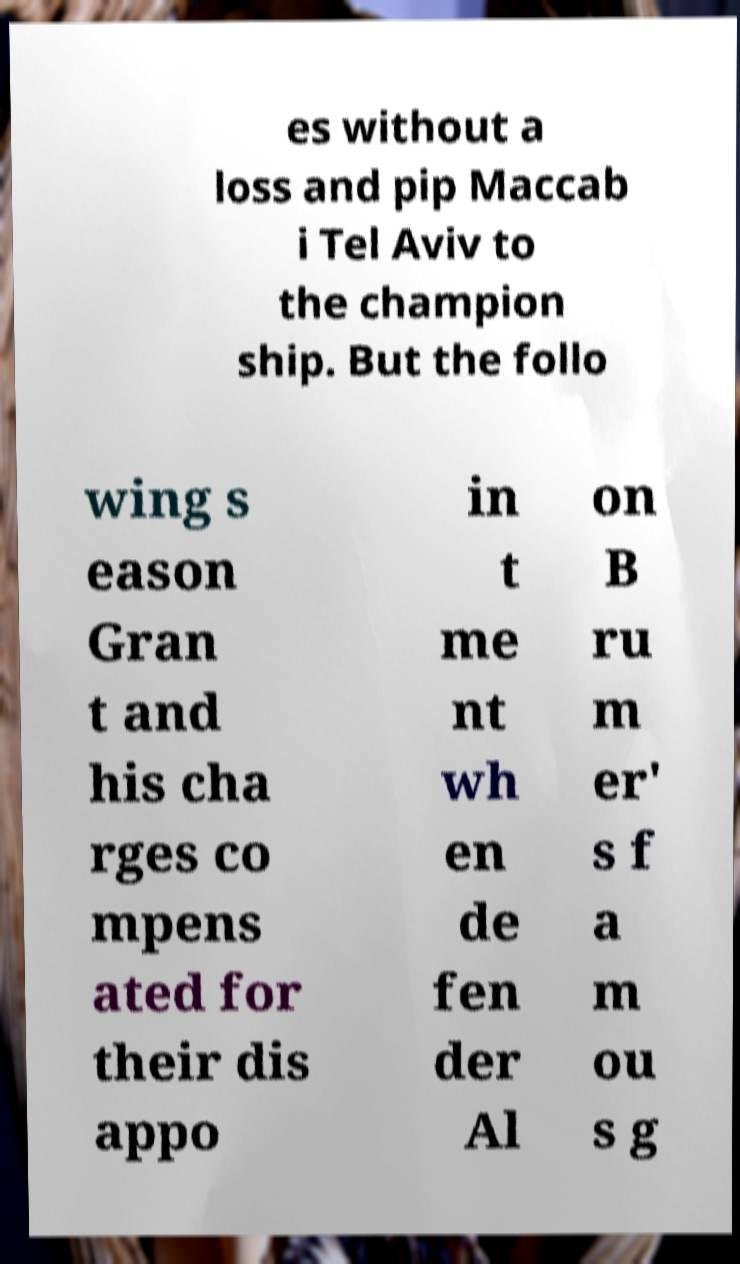Can you accurately transcribe the text from the provided image for me? es without a loss and pip Maccab i Tel Aviv to the champion ship. But the follo wing s eason Gran t and his cha rges co mpens ated for their dis appo in t me nt wh en de fen der Al on B ru m er' s f a m ou s g 